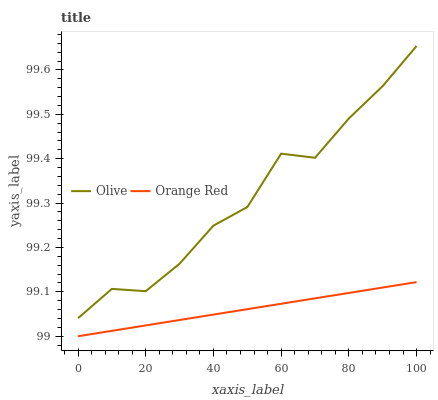Does Orange Red have the minimum area under the curve?
Answer yes or no. Yes. Does Olive have the maximum area under the curve?
Answer yes or no. Yes. Does Orange Red have the maximum area under the curve?
Answer yes or no. No. Is Orange Red the smoothest?
Answer yes or no. Yes. Is Olive the roughest?
Answer yes or no. Yes. Is Orange Red the roughest?
Answer yes or no. No. Does Orange Red have the lowest value?
Answer yes or no. Yes. Does Olive have the highest value?
Answer yes or no. Yes. Does Orange Red have the highest value?
Answer yes or no. No. Is Orange Red less than Olive?
Answer yes or no. Yes. Is Olive greater than Orange Red?
Answer yes or no. Yes. Does Orange Red intersect Olive?
Answer yes or no. No. 